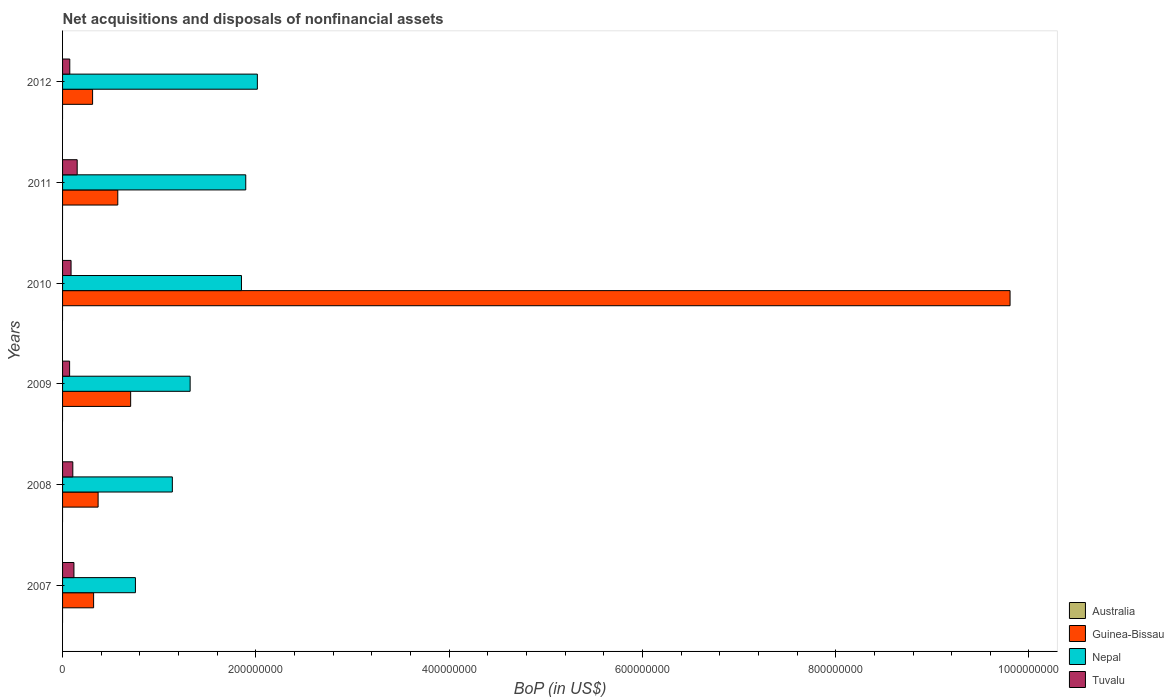How many different coloured bars are there?
Your answer should be very brief. 3. How many bars are there on the 1st tick from the top?
Keep it short and to the point. 3. How many bars are there on the 1st tick from the bottom?
Offer a very short reply. 3. In how many cases, is the number of bars for a given year not equal to the number of legend labels?
Keep it short and to the point. 6. What is the Balance of Payments in Guinea-Bissau in 2008?
Keep it short and to the point. 3.68e+07. Across all years, what is the maximum Balance of Payments in Guinea-Bissau?
Give a very brief answer. 9.80e+08. Across all years, what is the minimum Balance of Payments in Guinea-Bissau?
Offer a terse response. 3.11e+07. In which year was the Balance of Payments in Tuvalu maximum?
Your answer should be very brief. 2011. What is the total Balance of Payments in Guinea-Bissau in the graph?
Your answer should be compact. 1.21e+09. What is the difference between the Balance of Payments in Nepal in 2007 and that in 2010?
Offer a very short reply. -1.10e+08. What is the difference between the Balance of Payments in Australia in 2011 and the Balance of Payments in Guinea-Bissau in 2008?
Your response must be concise. -3.68e+07. In the year 2009, what is the difference between the Balance of Payments in Nepal and Balance of Payments in Tuvalu?
Give a very brief answer. 1.25e+08. What is the ratio of the Balance of Payments in Nepal in 2007 to that in 2010?
Your answer should be very brief. 0.41. What is the difference between the highest and the second highest Balance of Payments in Guinea-Bissau?
Your answer should be very brief. 9.10e+08. What is the difference between the highest and the lowest Balance of Payments in Tuvalu?
Offer a very short reply. 7.84e+06. Is the sum of the Balance of Payments in Nepal in 2009 and 2010 greater than the maximum Balance of Payments in Australia across all years?
Give a very brief answer. Yes. Is it the case that in every year, the sum of the Balance of Payments in Tuvalu and Balance of Payments in Nepal is greater than the sum of Balance of Payments in Guinea-Bissau and Balance of Payments in Australia?
Give a very brief answer. Yes. How many bars are there?
Your answer should be very brief. 18. What is the difference between two consecutive major ticks on the X-axis?
Give a very brief answer. 2.00e+08. Does the graph contain any zero values?
Make the answer very short. Yes. Where does the legend appear in the graph?
Make the answer very short. Bottom right. How many legend labels are there?
Keep it short and to the point. 4. What is the title of the graph?
Offer a very short reply. Net acquisitions and disposals of nonfinancial assets. Does "Timor-Leste" appear as one of the legend labels in the graph?
Offer a terse response. No. What is the label or title of the X-axis?
Offer a terse response. BoP (in US$). What is the BoP (in US$) in Guinea-Bissau in 2007?
Give a very brief answer. 3.21e+07. What is the BoP (in US$) in Nepal in 2007?
Offer a terse response. 7.54e+07. What is the BoP (in US$) in Tuvalu in 2007?
Offer a very short reply. 1.18e+07. What is the BoP (in US$) in Australia in 2008?
Your answer should be very brief. 0. What is the BoP (in US$) of Guinea-Bissau in 2008?
Make the answer very short. 3.68e+07. What is the BoP (in US$) in Nepal in 2008?
Your response must be concise. 1.14e+08. What is the BoP (in US$) in Tuvalu in 2008?
Provide a short and direct response. 1.06e+07. What is the BoP (in US$) of Guinea-Bissau in 2009?
Make the answer very short. 7.05e+07. What is the BoP (in US$) of Nepal in 2009?
Provide a short and direct response. 1.32e+08. What is the BoP (in US$) in Tuvalu in 2009?
Provide a succinct answer. 7.29e+06. What is the BoP (in US$) in Guinea-Bissau in 2010?
Your answer should be very brief. 9.80e+08. What is the BoP (in US$) in Nepal in 2010?
Make the answer very short. 1.85e+08. What is the BoP (in US$) in Tuvalu in 2010?
Give a very brief answer. 8.80e+06. What is the BoP (in US$) in Guinea-Bissau in 2011?
Offer a very short reply. 5.71e+07. What is the BoP (in US$) in Nepal in 2011?
Offer a terse response. 1.90e+08. What is the BoP (in US$) of Tuvalu in 2011?
Make the answer very short. 1.51e+07. What is the BoP (in US$) in Guinea-Bissau in 2012?
Your answer should be compact. 3.11e+07. What is the BoP (in US$) of Nepal in 2012?
Give a very brief answer. 2.02e+08. What is the BoP (in US$) of Tuvalu in 2012?
Your answer should be very brief. 7.47e+06. Across all years, what is the maximum BoP (in US$) in Guinea-Bissau?
Offer a terse response. 9.80e+08. Across all years, what is the maximum BoP (in US$) in Nepal?
Make the answer very short. 2.02e+08. Across all years, what is the maximum BoP (in US$) in Tuvalu?
Offer a terse response. 1.51e+07. Across all years, what is the minimum BoP (in US$) in Guinea-Bissau?
Your response must be concise. 3.11e+07. Across all years, what is the minimum BoP (in US$) in Nepal?
Make the answer very short. 7.54e+07. Across all years, what is the minimum BoP (in US$) in Tuvalu?
Your response must be concise. 7.29e+06. What is the total BoP (in US$) of Australia in the graph?
Your answer should be compact. 0. What is the total BoP (in US$) in Guinea-Bissau in the graph?
Give a very brief answer. 1.21e+09. What is the total BoP (in US$) of Nepal in the graph?
Offer a very short reply. 8.97e+08. What is the total BoP (in US$) of Tuvalu in the graph?
Ensure brevity in your answer.  6.11e+07. What is the difference between the BoP (in US$) in Guinea-Bissau in 2007 and that in 2008?
Your answer should be very brief. -4.66e+06. What is the difference between the BoP (in US$) of Nepal in 2007 and that in 2008?
Your response must be concise. -3.82e+07. What is the difference between the BoP (in US$) in Tuvalu in 2007 and that in 2008?
Give a very brief answer. 1.16e+06. What is the difference between the BoP (in US$) in Guinea-Bissau in 2007 and that in 2009?
Offer a very short reply. -3.83e+07. What is the difference between the BoP (in US$) of Nepal in 2007 and that in 2009?
Ensure brevity in your answer.  -5.66e+07. What is the difference between the BoP (in US$) in Tuvalu in 2007 and that in 2009?
Make the answer very short. 4.48e+06. What is the difference between the BoP (in US$) of Guinea-Bissau in 2007 and that in 2010?
Keep it short and to the point. -9.48e+08. What is the difference between the BoP (in US$) of Nepal in 2007 and that in 2010?
Keep it short and to the point. -1.10e+08. What is the difference between the BoP (in US$) of Tuvalu in 2007 and that in 2010?
Offer a very short reply. 2.97e+06. What is the difference between the BoP (in US$) in Guinea-Bissau in 2007 and that in 2011?
Ensure brevity in your answer.  -2.50e+07. What is the difference between the BoP (in US$) in Nepal in 2007 and that in 2011?
Provide a short and direct response. -1.14e+08. What is the difference between the BoP (in US$) in Tuvalu in 2007 and that in 2011?
Your response must be concise. -3.36e+06. What is the difference between the BoP (in US$) in Guinea-Bissau in 2007 and that in 2012?
Provide a succinct answer. 1.05e+06. What is the difference between the BoP (in US$) of Nepal in 2007 and that in 2012?
Keep it short and to the point. -1.26e+08. What is the difference between the BoP (in US$) in Tuvalu in 2007 and that in 2012?
Ensure brevity in your answer.  4.30e+06. What is the difference between the BoP (in US$) in Guinea-Bissau in 2008 and that in 2009?
Give a very brief answer. -3.37e+07. What is the difference between the BoP (in US$) in Nepal in 2008 and that in 2009?
Your answer should be compact. -1.84e+07. What is the difference between the BoP (in US$) in Tuvalu in 2008 and that in 2009?
Keep it short and to the point. 3.32e+06. What is the difference between the BoP (in US$) in Guinea-Bissau in 2008 and that in 2010?
Make the answer very short. -9.44e+08. What is the difference between the BoP (in US$) in Nepal in 2008 and that in 2010?
Ensure brevity in your answer.  -7.15e+07. What is the difference between the BoP (in US$) of Tuvalu in 2008 and that in 2010?
Your response must be concise. 1.81e+06. What is the difference between the BoP (in US$) of Guinea-Bissau in 2008 and that in 2011?
Ensure brevity in your answer.  -2.04e+07. What is the difference between the BoP (in US$) of Nepal in 2008 and that in 2011?
Give a very brief answer. -7.60e+07. What is the difference between the BoP (in US$) of Tuvalu in 2008 and that in 2011?
Provide a succinct answer. -4.52e+06. What is the difference between the BoP (in US$) in Guinea-Bissau in 2008 and that in 2012?
Keep it short and to the point. 5.71e+06. What is the difference between the BoP (in US$) of Nepal in 2008 and that in 2012?
Offer a very short reply. -8.80e+07. What is the difference between the BoP (in US$) in Tuvalu in 2008 and that in 2012?
Ensure brevity in your answer.  3.14e+06. What is the difference between the BoP (in US$) of Guinea-Bissau in 2009 and that in 2010?
Provide a succinct answer. -9.10e+08. What is the difference between the BoP (in US$) in Nepal in 2009 and that in 2010?
Give a very brief answer. -5.31e+07. What is the difference between the BoP (in US$) in Tuvalu in 2009 and that in 2010?
Offer a very short reply. -1.51e+06. What is the difference between the BoP (in US$) in Guinea-Bissau in 2009 and that in 2011?
Your answer should be very brief. 1.33e+07. What is the difference between the BoP (in US$) of Nepal in 2009 and that in 2011?
Give a very brief answer. -5.75e+07. What is the difference between the BoP (in US$) of Tuvalu in 2009 and that in 2011?
Your response must be concise. -7.84e+06. What is the difference between the BoP (in US$) of Guinea-Bissau in 2009 and that in 2012?
Keep it short and to the point. 3.94e+07. What is the difference between the BoP (in US$) in Nepal in 2009 and that in 2012?
Your answer should be very brief. -6.96e+07. What is the difference between the BoP (in US$) in Tuvalu in 2009 and that in 2012?
Your answer should be very brief. -1.80e+05. What is the difference between the BoP (in US$) of Guinea-Bissau in 2010 and that in 2011?
Keep it short and to the point. 9.23e+08. What is the difference between the BoP (in US$) in Nepal in 2010 and that in 2011?
Ensure brevity in your answer.  -4.43e+06. What is the difference between the BoP (in US$) in Tuvalu in 2010 and that in 2011?
Your answer should be compact. -6.33e+06. What is the difference between the BoP (in US$) of Guinea-Bissau in 2010 and that in 2012?
Your answer should be very brief. 9.49e+08. What is the difference between the BoP (in US$) of Nepal in 2010 and that in 2012?
Your response must be concise. -1.64e+07. What is the difference between the BoP (in US$) of Tuvalu in 2010 and that in 2012?
Keep it short and to the point. 1.33e+06. What is the difference between the BoP (in US$) in Guinea-Bissau in 2011 and that in 2012?
Your response must be concise. 2.61e+07. What is the difference between the BoP (in US$) in Nepal in 2011 and that in 2012?
Your response must be concise. -1.20e+07. What is the difference between the BoP (in US$) of Tuvalu in 2011 and that in 2012?
Keep it short and to the point. 7.66e+06. What is the difference between the BoP (in US$) of Guinea-Bissau in 2007 and the BoP (in US$) of Nepal in 2008?
Ensure brevity in your answer.  -8.15e+07. What is the difference between the BoP (in US$) of Guinea-Bissau in 2007 and the BoP (in US$) of Tuvalu in 2008?
Offer a very short reply. 2.15e+07. What is the difference between the BoP (in US$) in Nepal in 2007 and the BoP (in US$) in Tuvalu in 2008?
Your response must be concise. 6.48e+07. What is the difference between the BoP (in US$) of Guinea-Bissau in 2007 and the BoP (in US$) of Nepal in 2009?
Give a very brief answer. -9.99e+07. What is the difference between the BoP (in US$) of Guinea-Bissau in 2007 and the BoP (in US$) of Tuvalu in 2009?
Provide a succinct answer. 2.48e+07. What is the difference between the BoP (in US$) in Nepal in 2007 and the BoP (in US$) in Tuvalu in 2009?
Offer a terse response. 6.81e+07. What is the difference between the BoP (in US$) in Guinea-Bissau in 2007 and the BoP (in US$) in Nepal in 2010?
Offer a very short reply. -1.53e+08. What is the difference between the BoP (in US$) in Guinea-Bissau in 2007 and the BoP (in US$) in Tuvalu in 2010?
Give a very brief answer. 2.33e+07. What is the difference between the BoP (in US$) of Nepal in 2007 and the BoP (in US$) of Tuvalu in 2010?
Ensure brevity in your answer.  6.66e+07. What is the difference between the BoP (in US$) in Guinea-Bissau in 2007 and the BoP (in US$) in Nepal in 2011?
Provide a short and direct response. -1.57e+08. What is the difference between the BoP (in US$) of Guinea-Bissau in 2007 and the BoP (in US$) of Tuvalu in 2011?
Keep it short and to the point. 1.70e+07. What is the difference between the BoP (in US$) of Nepal in 2007 and the BoP (in US$) of Tuvalu in 2011?
Keep it short and to the point. 6.03e+07. What is the difference between the BoP (in US$) of Guinea-Bissau in 2007 and the BoP (in US$) of Nepal in 2012?
Offer a very short reply. -1.69e+08. What is the difference between the BoP (in US$) of Guinea-Bissau in 2007 and the BoP (in US$) of Tuvalu in 2012?
Your answer should be very brief. 2.47e+07. What is the difference between the BoP (in US$) in Nepal in 2007 and the BoP (in US$) in Tuvalu in 2012?
Ensure brevity in your answer.  6.79e+07. What is the difference between the BoP (in US$) of Guinea-Bissau in 2008 and the BoP (in US$) of Nepal in 2009?
Ensure brevity in your answer.  -9.52e+07. What is the difference between the BoP (in US$) of Guinea-Bissau in 2008 and the BoP (in US$) of Tuvalu in 2009?
Make the answer very short. 2.95e+07. What is the difference between the BoP (in US$) in Nepal in 2008 and the BoP (in US$) in Tuvalu in 2009?
Your answer should be compact. 1.06e+08. What is the difference between the BoP (in US$) in Guinea-Bissau in 2008 and the BoP (in US$) in Nepal in 2010?
Your response must be concise. -1.48e+08. What is the difference between the BoP (in US$) of Guinea-Bissau in 2008 and the BoP (in US$) of Tuvalu in 2010?
Offer a terse response. 2.80e+07. What is the difference between the BoP (in US$) in Nepal in 2008 and the BoP (in US$) in Tuvalu in 2010?
Offer a very short reply. 1.05e+08. What is the difference between the BoP (in US$) of Guinea-Bissau in 2008 and the BoP (in US$) of Nepal in 2011?
Your response must be concise. -1.53e+08. What is the difference between the BoP (in US$) of Guinea-Bissau in 2008 and the BoP (in US$) of Tuvalu in 2011?
Keep it short and to the point. 2.17e+07. What is the difference between the BoP (in US$) in Nepal in 2008 and the BoP (in US$) in Tuvalu in 2011?
Your response must be concise. 9.85e+07. What is the difference between the BoP (in US$) of Guinea-Bissau in 2008 and the BoP (in US$) of Nepal in 2012?
Give a very brief answer. -1.65e+08. What is the difference between the BoP (in US$) of Guinea-Bissau in 2008 and the BoP (in US$) of Tuvalu in 2012?
Your response must be concise. 2.93e+07. What is the difference between the BoP (in US$) of Nepal in 2008 and the BoP (in US$) of Tuvalu in 2012?
Keep it short and to the point. 1.06e+08. What is the difference between the BoP (in US$) of Guinea-Bissau in 2009 and the BoP (in US$) of Nepal in 2010?
Your answer should be compact. -1.15e+08. What is the difference between the BoP (in US$) of Guinea-Bissau in 2009 and the BoP (in US$) of Tuvalu in 2010?
Provide a short and direct response. 6.17e+07. What is the difference between the BoP (in US$) of Nepal in 2009 and the BoP (in US$) of Tuvalu in 2010?
Keep it short and to the point. 1.23e+08. What is the difference between the BoP (in US$) of Guinea-Bissau in 2009 and the BoP (in US$) of Nepal in 2011?
Give a very brief answer. -1.19e+08. What is the difference between the BoP (in US$) of Guinea-Bissau in 2009 and the BoP (in US$) of Tuvalu in 2011?
Offer a terse response. 5.53e+07. What is the difference between the BoP (in US$) of Nepal in 2009 and the BoP (in US$) of Tuvalu in 2011?
Offer a very short reply. 1.17e+08. What is the difference between the BoP (in US$) in Guinea-Bissau in 2009 and the BoP (in US$) in Nepal in 2012?
Provide a succinct answer. -1.31e+08. What is the difference between the BoP (in US$) of Guinea-Bissau in 2009 and the BoP (in US$) of Tuvalu in 2012?
Provide a succinct answer. 6.30e+07. What is the difference between the BoP (in US$) of Nepal in 2009 and the BoP (in US$) of Tuvalu in 2012?
Offer a terse response. 1.25e+08. What is the difference between the BoP (in US$) of Guinea-Bissau in 2010 and the BoP (in US$) of Nepal in 2011?
Provide a succinct answer. 7.91e+08. What is the difference between the BoP (in US$) of Guinea-Bissau in 2010 and the BoP (in US$) of Tuvalu in 2011?
Keep it short and to the point. 9.65e+08. What is the difference between the BoP (in US$) of Nepal in 2010 and the BoP (in US$) of Tuvalu in 2011?
Your answer should be very brief. 1.70e+08. What is the difference between the BoP (in US$) of Guinea-Bissau in 2010 and the BoP (in US$) of Nepal in 2012?
Make the answer very short. 7.79e+08. What is the difference between the BoP (in US$) in Guinea-Bissau in 2010 and the BoP (in US$) in Tuvalu in 2012?
Ensure brevity in your answer.  9.73e+08. What is the difference between the BoP (in US$) in Nepal in 2010 and the BoP (in US$) in Tuvalu in 2012?
Your answer should be compact. 1.78e+08. What is the difference between the BoP (in US$) of Guinea-Bissau in 2011 and the BoP (in US$) of Nepal in 2012?
Provide a succinct answer. -1.44e+08. What is the difference between the BoP (in US$) in Guinea-Bissau in 2011 and the BoP (in US$) in Tuvalu in 2012?
Keep it short and to the point. 4.97e+07. What is the difference between the BoP (in US$) in Nepal in 2011 and the BoP (in US$) in Tuvalu in 2012?
Provide a short and direct response. 1.82e+08. What is the average BoP (in US$) of Australia per year?
Offer a terse response. 0. What is the average BoP (in US$) in Guinea-Bissau per year?
Your response must be concise. 2.01e+08. What is the average BoP (in US$) in Nepal per year?
Provide a short and direct response. 1.50e+08. What is the average BoP (in US$) of Tuvalu per year?
Offer a terse response. 1.02e+07. In the year 2007, what is the difference between the BoP (in US$) of Guinea-Bissau and BoP (in US$) of Nepal?
Your answer should be compact. -4.33e+07. In the year 2007, what is the difference between the BoP (in US$) in Guinea-Bissau and BoP (in US$) in Tuvalu?
Provide a succinct answer. 2.04e+07. In the year 2007, what is the difference between the BoP (in US$) in Nepal and BoP (in US$) in Tuvalu?
Ensure brevity in your answer.  6.36e+07. In the year 2008, what is the difference between the BoP (in US$) of Guinea-Bissau and BoP (in US$) of Nepal?
Give a very brief answer. -7.68e+07. In the year 2008, what is the difference between the BoP (in US$) of Guinea-Bissau and BoP (in US$) of Tuvalu?
Offer a very short reply. 2.62e+07. In the year 2008, what is the difference between the BoP (in US$) of Nepal and BoP (in US$) of Tuvalu?
Your answer should be compact. 1.03e+08. In the year 2009, what is the difference between the BoP (in US$) of Guinea-Bissau and BoP (in US$) of Nepal?
Provide a succinct answer. -6.16e+07. In the year 2009, what is the difference between the BoP (in US$) of Guinea-Bissau and BoP (in US$) of Tuvalu?
Provide a succinct answer. 6.32e+07. In the year 2009, what is the difference between the BoP (in US$) of Nepal and BoP (in US$) of Tuvalu?
Give a very brief answer. 1.25e+08. In the year 2010, what is the difference between the BoP (in US$) in Guinea-Bissau and BoP (in US$) in Nepal?
Your answer should be very brief. 7.95e+08. In the year 2010, what is the difference between the BoP (in US$) of Guinea-Bissau and BoP (in US$) of Tuvalu?
Give a very brief answer. 9.72e+08. In the year 2010, what is the difference between the BoP (in US$) in Nepal and BoP (in US$) in Tuvalu?
Keep it short and to the point. 1.76e+08. In the year 2011, what is the difference between the BoP (in US$) in Guinea-Bissau and BoP (in US$) in Nepal?
Your answer should be very brief. -1.32e+08. In the year 2011, what is the difference between the BoP (in US$) in Guinea-Bissau and BoP (in US$) in Tuvalu?
Your answer should be very brief. 4.20e+07. In the year 2011, what is the difference between the BoP (in US$) in Nepal and BoP (in US$) in Tuvalu?
Your answer should be very brief. 1.74e+08. In the year 2012, what is the difference between the BoP (in US$) in Guinea-Bissau and BoP (in US$) in Nepal?
Provide a short and direct response. -1.70e+08. In the year 2012, what is the difference between the BoP (in US$) of Guinea-Bissau and BoP (in US$) of Tuvalu?
Keep it short and to the point. 2.36e+07. In the year 2012, what is the difference between the BoP (in US$) of Nepal and BoP (in US$) of Tuvalu?
Offer a terse response. 1.94e+08. What is the ratio of the BoP (in US$) in Guinea-Bissau in 2007 to that in 2008?
Provide a succinct answer. 0.87. What is the ratio of the BoP (in US$) in Nepal in 2007 to that in 2008?
Your answer should be compact. 0.66. What is the ratio of the BoP (in US$) in Tuvalu in 2007 to that in 2008?
Your response must be concise. 1.11. What is the ratio of the BoP (in US$) of Guinea-Bissau in 2007 to that in 2009?
Provide a succinct answer. 0.46. What is the ratio of the BoP (in US$) of Nepal in 2007 to that in 2009?
Your answer should be very brief. 0.57. What is the ratio of the BoP (in US$) in Tuvalu in 2007 to that in 2009?
Provide a succinct answer. 1.61. What is the ratio of the BoP (in US$) of Guinea-Bissau in 2007 to that in 2010?
Keep it short and to the point. 0.03. What is the ratio of the BoP (in US$) in Nepal in 2007 to that in 2010?
Give a very brief answer. 0.41. What is the ratio of the BoP (in US$) in Tuvalu in 2007 to that in 2010?
Ensure brevity in your answer.  1.34. What is the ratio of the BoP (in US$) in Guinea-Bissau in 2007 to that in 2011?
Keep it short and to the point. 0.56. What is the ratio of the BoP (in US$) in Nepal in 2007 to that in 2011?
Offer a terse response. 0.4. What is the ratio of the BoP (in US$) of Tuvalu in 2007 to that in 2011?
Offer a very short reply. 0.78. What is the ratio of the BoP (in US$) of Guinea-Bissau in 2007 to that in 2012?
Keep it short and to the point. 1.03. What is the ratio of the BoP (in US$) in Nepal in 2007 to that in 2012?
Give a very brief answer. 0.37. What is the ratio of the BoP (in US$) in Tuvalu in 2007 to that in 2012?
Offer a terse response. 1.58. What is the ratio of the BoP (in US$) of Guinea-Bissau in 2008 to that in 2009?
Your answer should be very brief. 0.52. What is the ratio of the BoP (in US$) of Nepal in 2008 to that in 2009?
Offer a terse response. 0.86. What is the ratio of the BoP (in US$) of Tuvalu in 2008 to that in 2009?
Your answer should be very brief. 1.46. What is the ratio of the BoP (in US$) of Guinea-Bissau in 2008 to that in 2010?
Give a very brief answer. 0.04. What is the ratio of the BoP (in US$) in Nepal in 2008 to that in 2010?
Give a very brief answer. 0.61. What is the ratio of the BoP (in US$) of Tuvalu in 2008 to that in 2010?
Your answer should be compact. 1.21. What is the ratio of the BoP (in US$) in Guinea-Bissau in 2008 to that in 2011?
Give a very brief answer. 0.64. What is the ratio of the BoP (in US$) in Nepal in 2008 to that in 2011?
Provide a succinct answer. 0.6. What is the ratio of the BoP (in US$) in Tuvalu in 2008 to that in 2011?
Make the answer very short. 0.7. What is the ratio of the BoP (in US$) in Guinea-Bissau in 2008 to that in 2012?
Offer a terse response. 1.18. What is the ratio of the BoP (in US$) in Nepal in 2008 to that in 2012?
Offer a very short reply. 0.56. What is the ratio of the BoP (in US$) in Tuvalu in 2008 to that in 2012?
Offer a terse response. 1.42. What is the ratio of the BoP (in US$) of Guinea-Bissau in 2009 to that in 2010?
Ensure brevity in your answer.  0.07. What is the ratio of the BoP (in US$) in Nepal in 2009 to that in 2010?
Ensure brevity in your answer.  0.71. What is the ratio of the BoP (in US$) in Tuvalu in 2009 to that in 2010?
Offer a very short reply. 0.83. What is the ratio of the BoP (in US$) of Guinea-Bissau in 2009 to that in 2011?
Your answer should be very brief. 1.23. What is the ratio of the BoP (in US$) in Nepal in 2009 to that in 2011?
Provide a short and direct response. 0.7. What is the ratio of the BoP (in US$) of Tuvalu in 2009 to that in 2011?
Ensure brevity in your answer.  0.48. What is the ratio of the BoP (in US$) in Guinea-Bissau in 2009 to that in 2012?
Ensure brevity in your answer.  2.27. What is the ratio of the BoP (in US$) of Nepal in 2009 to that in 2012?
Provide a succinct answer. 0.65. What is the ratio of the BoP (in US$) in Tuvalu in 2009 to that in 2012?
Keep it short and to the point. 0.98. What is the ratio of the BoP (in US$) of Guinea-Bissau in 2010 to that in 2011?
Your answer should be compact. 17.16. What is the ratio of the BoP (in US$) in Nepal in 2010 to that in 2011?
Your answer should be very brief. 0.98. What is the ratio of the BoP (in US$) of Tuvalu in 2010 to that in 2011?
Offer a very short reply. 0.58. What is the ratio of the BoP (in US$) of Guinea-Bissau in 2010 to that in 2012?
Offer a very short reply. 31.55. What is the ratio of the BoP (in US$) of Nepal in 2010 to that in 2012?
Offer a terse response. 0.92. What is the ratio of the BoP (in US$) of Tuvalu in 2010 to that in 2012?
Offer a very short reply. 1.18. What is the ratio of the BoP (in US$) of Guinea-Bissau in 2011 to that in 2012?
Ensure brevity in your answer.  1.84. What is the ratio of the BoP (in US$) of Nepal in 2011 to that in 2012?
Make the answer very short. 0.94. What is the ratio of the BoP (in US$) in Tuvalu in 2011 to that in 2012?
Provide a succinct answer. 2.03. What is the difference between the highest and the second highest BoP (in US$) in Guinea-Bissau?
Ensure brevity in your answer.  9.10e+08. What is the difference between the highest and the second highest BoP (in US$) of Nepal?
Ensure brevity in your answer.  1.20e+07. What is the difference between the highest and the second highest BoP (in US$) in Tuvalu?
Your answer should be very brief. 3.36e+06. What is the difference between the highest and the lowest BoP (in US$) in Guinea-Bissau?
Your answer should be very brief. 9.49e+08. What is the difference between the highest and the lowest BoP (in US$) of Nepal?
Your answer should be very brief. 1.26e+08. What is the difference between the highest and the lowest BoP (in US$) in Tuvalu?
Keep it short and to the point. 7.84e+06. 